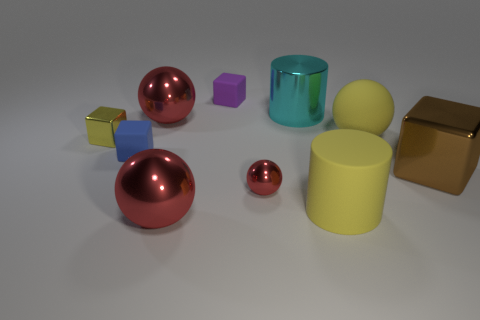Are there any patterns or consistency in the colors of the objects? The objects exhibit a variety of colors without a recurring pattern. They range from metallic hues like gold and chrome to solid colors such as red, yellow, and cyan. The colors are vivid, with each object featuring a distinct and uniform color, which contributes to the overall diversity in the image. 